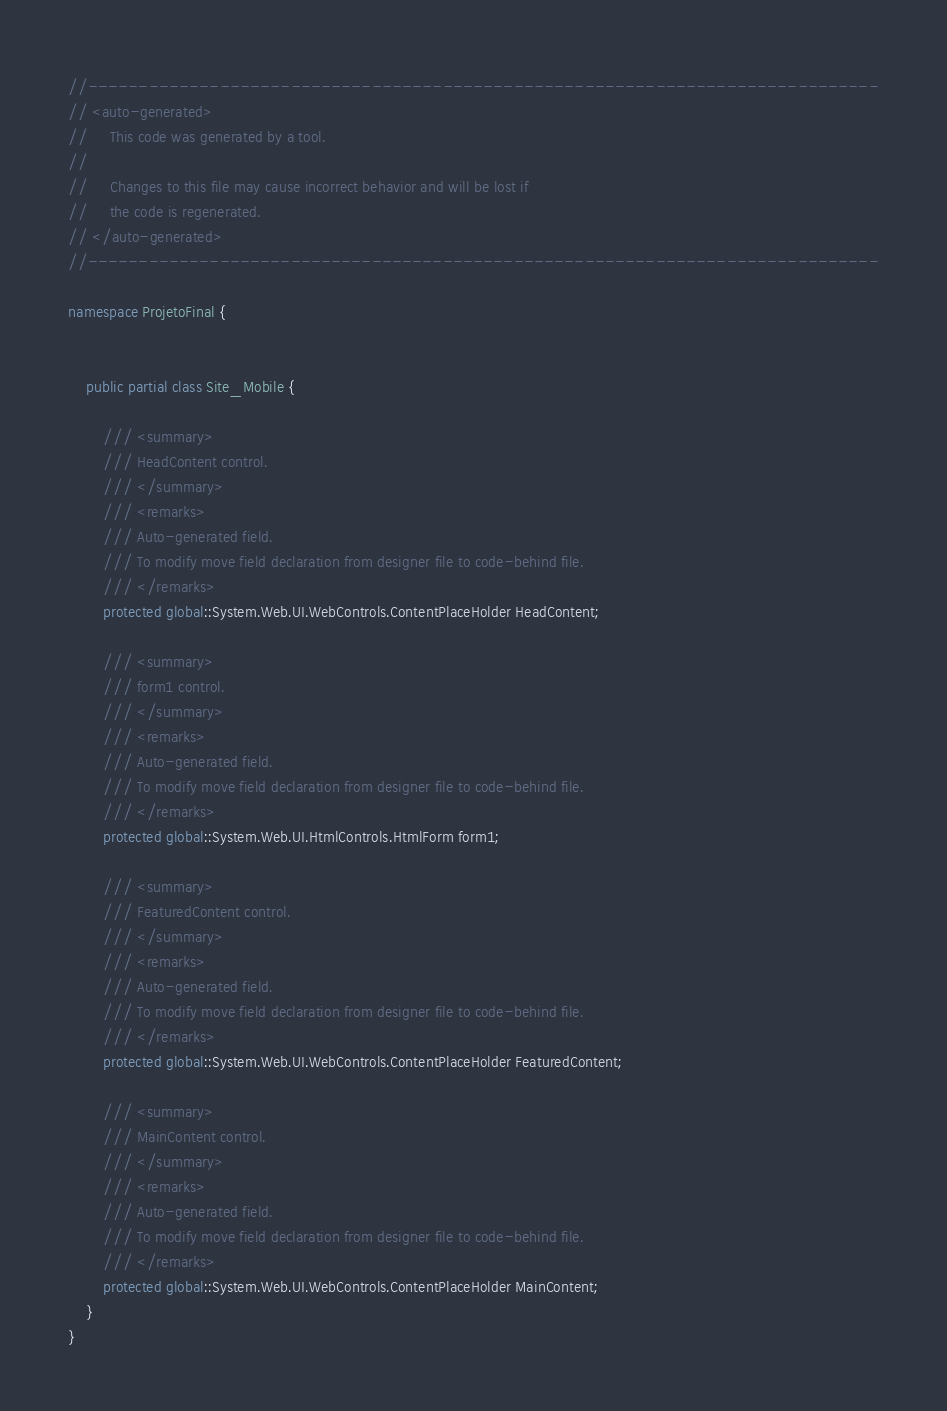Convert code to text. <code><loc_0><loc_0><loc_500><loc_500><_C#_>//------------------------------------------------------------------------------
// <auto-generated>
//     This code was generated by a tool.
//
//     Changes to this file may cause incorrect behavior and will be lost if
//     the code is regenerated. 
// </auto-generated>
//------------------------------------------------------------------------------

namespace ProjetoFinal {
    
    
    public partial class Site_Mobile {
        
        /// <summary>
        /// HeadContent control.
        /// </summary>
        /// <remarks>
        /// Auto-generated field.
        /// To modify move field declaration from designer file to code-behind file.
        /// </remarks>
        protected global::System.Web.UI.WebControls.ContentPlaceHolder HeadContent;
        
        /// <summary>
        /// form1 control.
        /// </summary>
        /// <remarks>
        /// Auto-generated field.
        /// To modify move field declaration from designer file to code-behind file.
        /// </remarks>
        protected global::System.Web.UI.HtmlControls.HtmlForm form1;
        
        /// <summary>
        /// FeaturedContent control.
        /// </summary>
        /// <remarks>
        /// Auto-generated field.
        /// To modify move field declaration from designer file to code-behind file.
        /// </remarks>
        protected global::System.Web.UI.WebControls.ContentPlaceHolder FeaturedContent;
        
        /// <summary>
        /// MainContent control.
        /// </summary>
        /// <remarks>
        /// Auto-generated field.
        /// To modify move field declaration from designer file to code-behind file.
        /// </remarks>
        protected global::System.Web.UI.WebControls.ContentPlaceHolder MainContent;
    }
}
</code> 